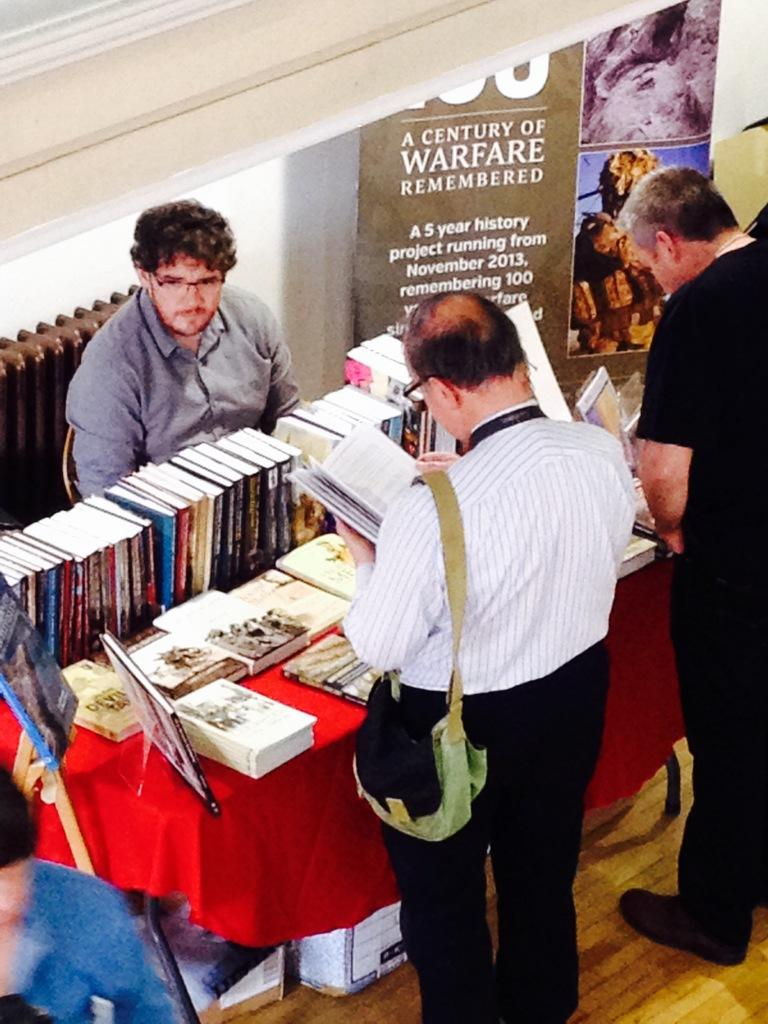<image>
Share a concise interpretation of the image provided. Three men at an exhibit about a century of warfare remembered. 